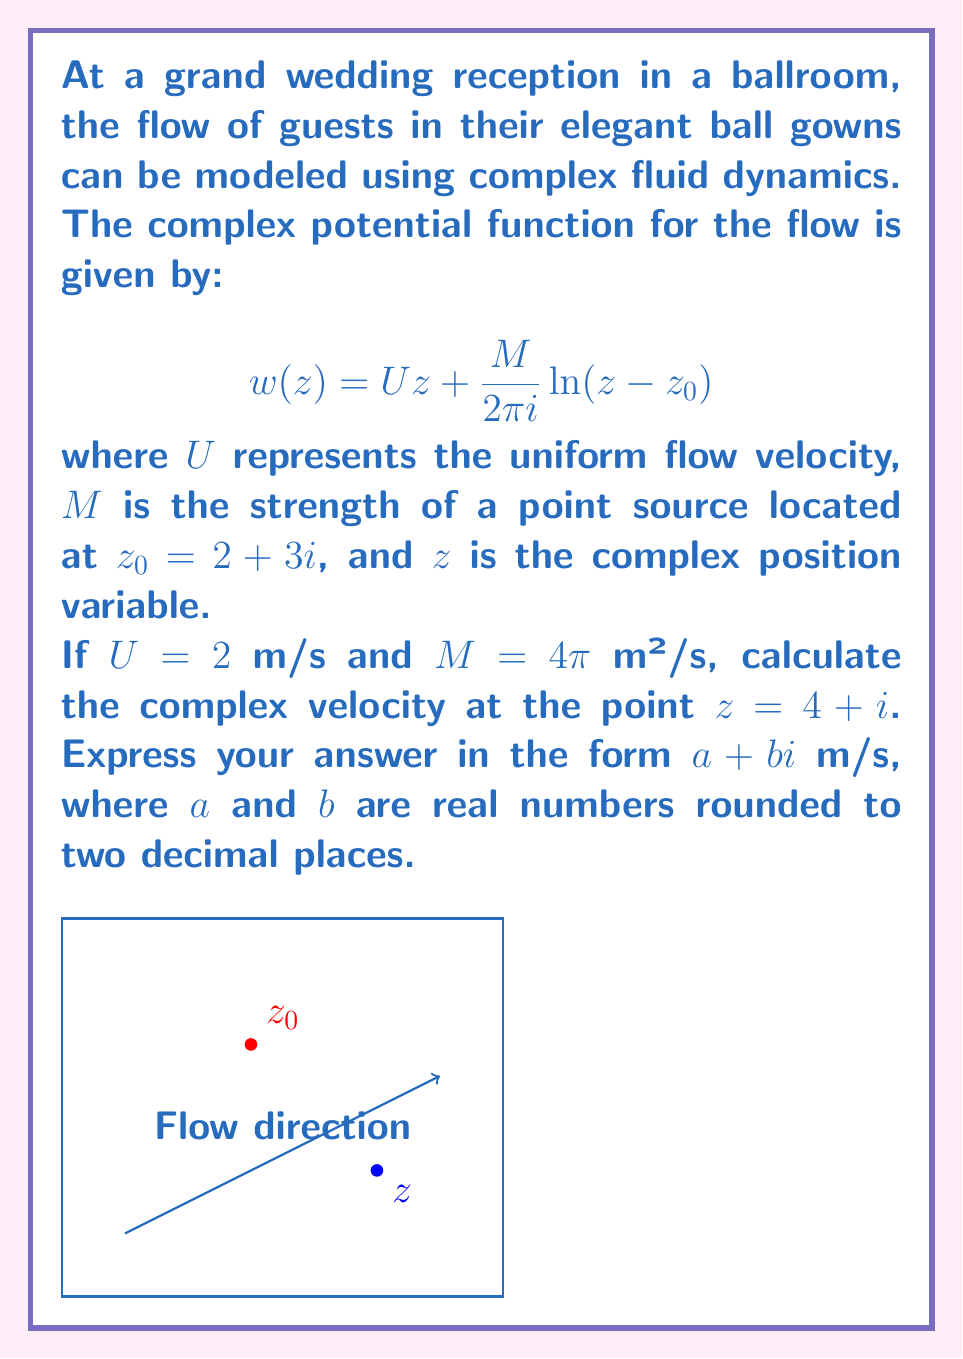Help me with this question. Let's approach this step-by-step:

1) The complex velocity $v(z)$ is given by the derivative of the complex potential function:

   $$v(z) = \frac{dw}{dz} = U + \frac{M}{2\pi i} \frac{1}{z - z_0}$$

2) We're given that $U = 2$ m/s, $M = 4\pi$ m²/s, and $z_0 = 2 + 3i$. Let's substitute these values:

   $$v(z) = 2 + \frac{4\pi}{2\pi i} \frac{1}{z - (2 + 3i)}$$

3) Simplify:

   $$v(z) = 2 + \frac{2}{i} \frac{1}{z - (2 + 3i)}$$

4) Now, we need to evaluate this at $z = 4 + i$. Let's substitute:

   $$v(4+i) = 2 + \frac{2}{i} \frac{1}{(4+i) - (2+3i)}$$

5) Simplify the denominator:

   $$v(4+i) = 2 + \frac{2}{i} \frac{1}{2-2i}$$

6) Multiply numerator and denominator by the complex conjugate of the denominator:

   $$v(4+i) = 2 + \frac{2}{i} \frac{2+2i}{(2-2i)(2+2i)} = 2 + \frac{2}{i} \frac{2+2i}{8}$$

7) Simplify:

   $$v(4+i) = 2 + \frac{1+i}{2i} = 2 + \frac{1+i}{2i} \cdot \frac{-i}{-i} = 2 + \frac{i-1}{2}$$

8) Separate real and imaginary parts:

   $$v(4+i) = (2 - \frac{1}{2}) + \frac{1}{2}i = 1.5 + 0.5i$$

Therefore, the complex velocity at $z = 4 + i$ is $1.5 + 0.5i$ m/s.
Answer: $1.50 + 0.50i$ m/s 